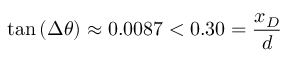Convert formula to latex. <formula><loc_0><loc_0><loc_500><loc_500>\tan \left ( \Delta \theta \right ) \approx 0 . 0 0 8 7 < 0 . 3 0 = \frac { x _ { D } } { d }</formula> 